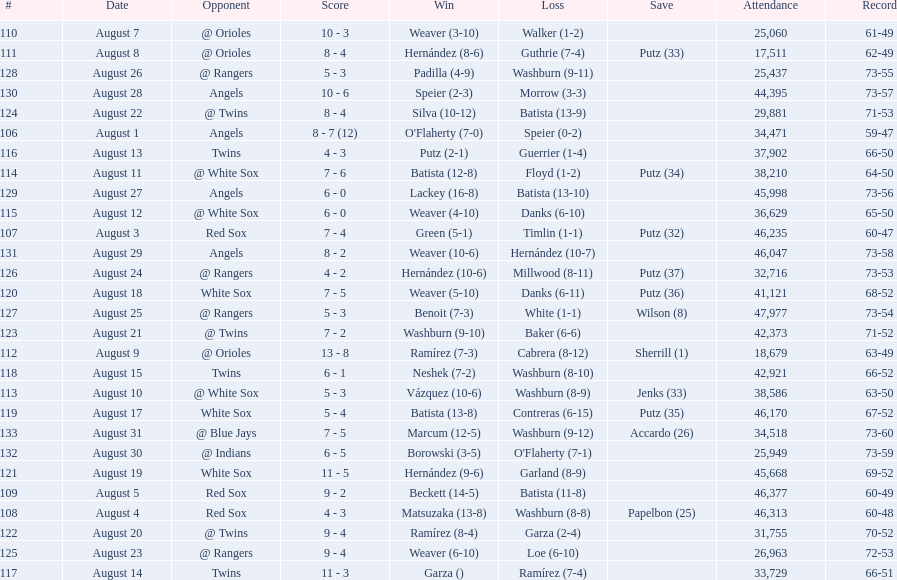Largest run differential 8. 